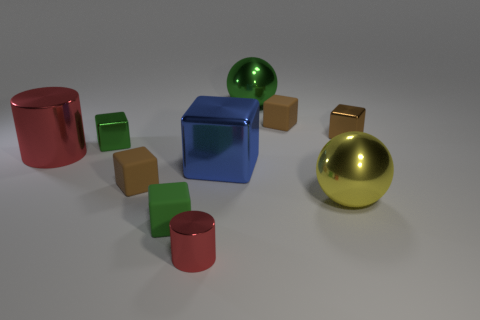How many brown blocks must be subtracted to get 1 brown blocks? 2 Subtract all blue cylinders. How many brown blocks are left? 3 Subtract all big metal blocks. How many blocks are left? 5 Subtract all green blocks. How many blocks are left? 4 Subtract all red blocks. Subtract all cyan cylinders. How many blocks are left? 6 Subtract all cubes. How many objects are left? 4 Subtract all green blocks. Subtract all big metallic spheres. How many objects are left? 6 Add 6 metallic cubes. How many metallic cubes are left? 9 Add 5 cyan metallic cylinders. How many cyan metallic cylinders exist? 5 Subtract 0 cyan cylinders. How many objects are left? 10 